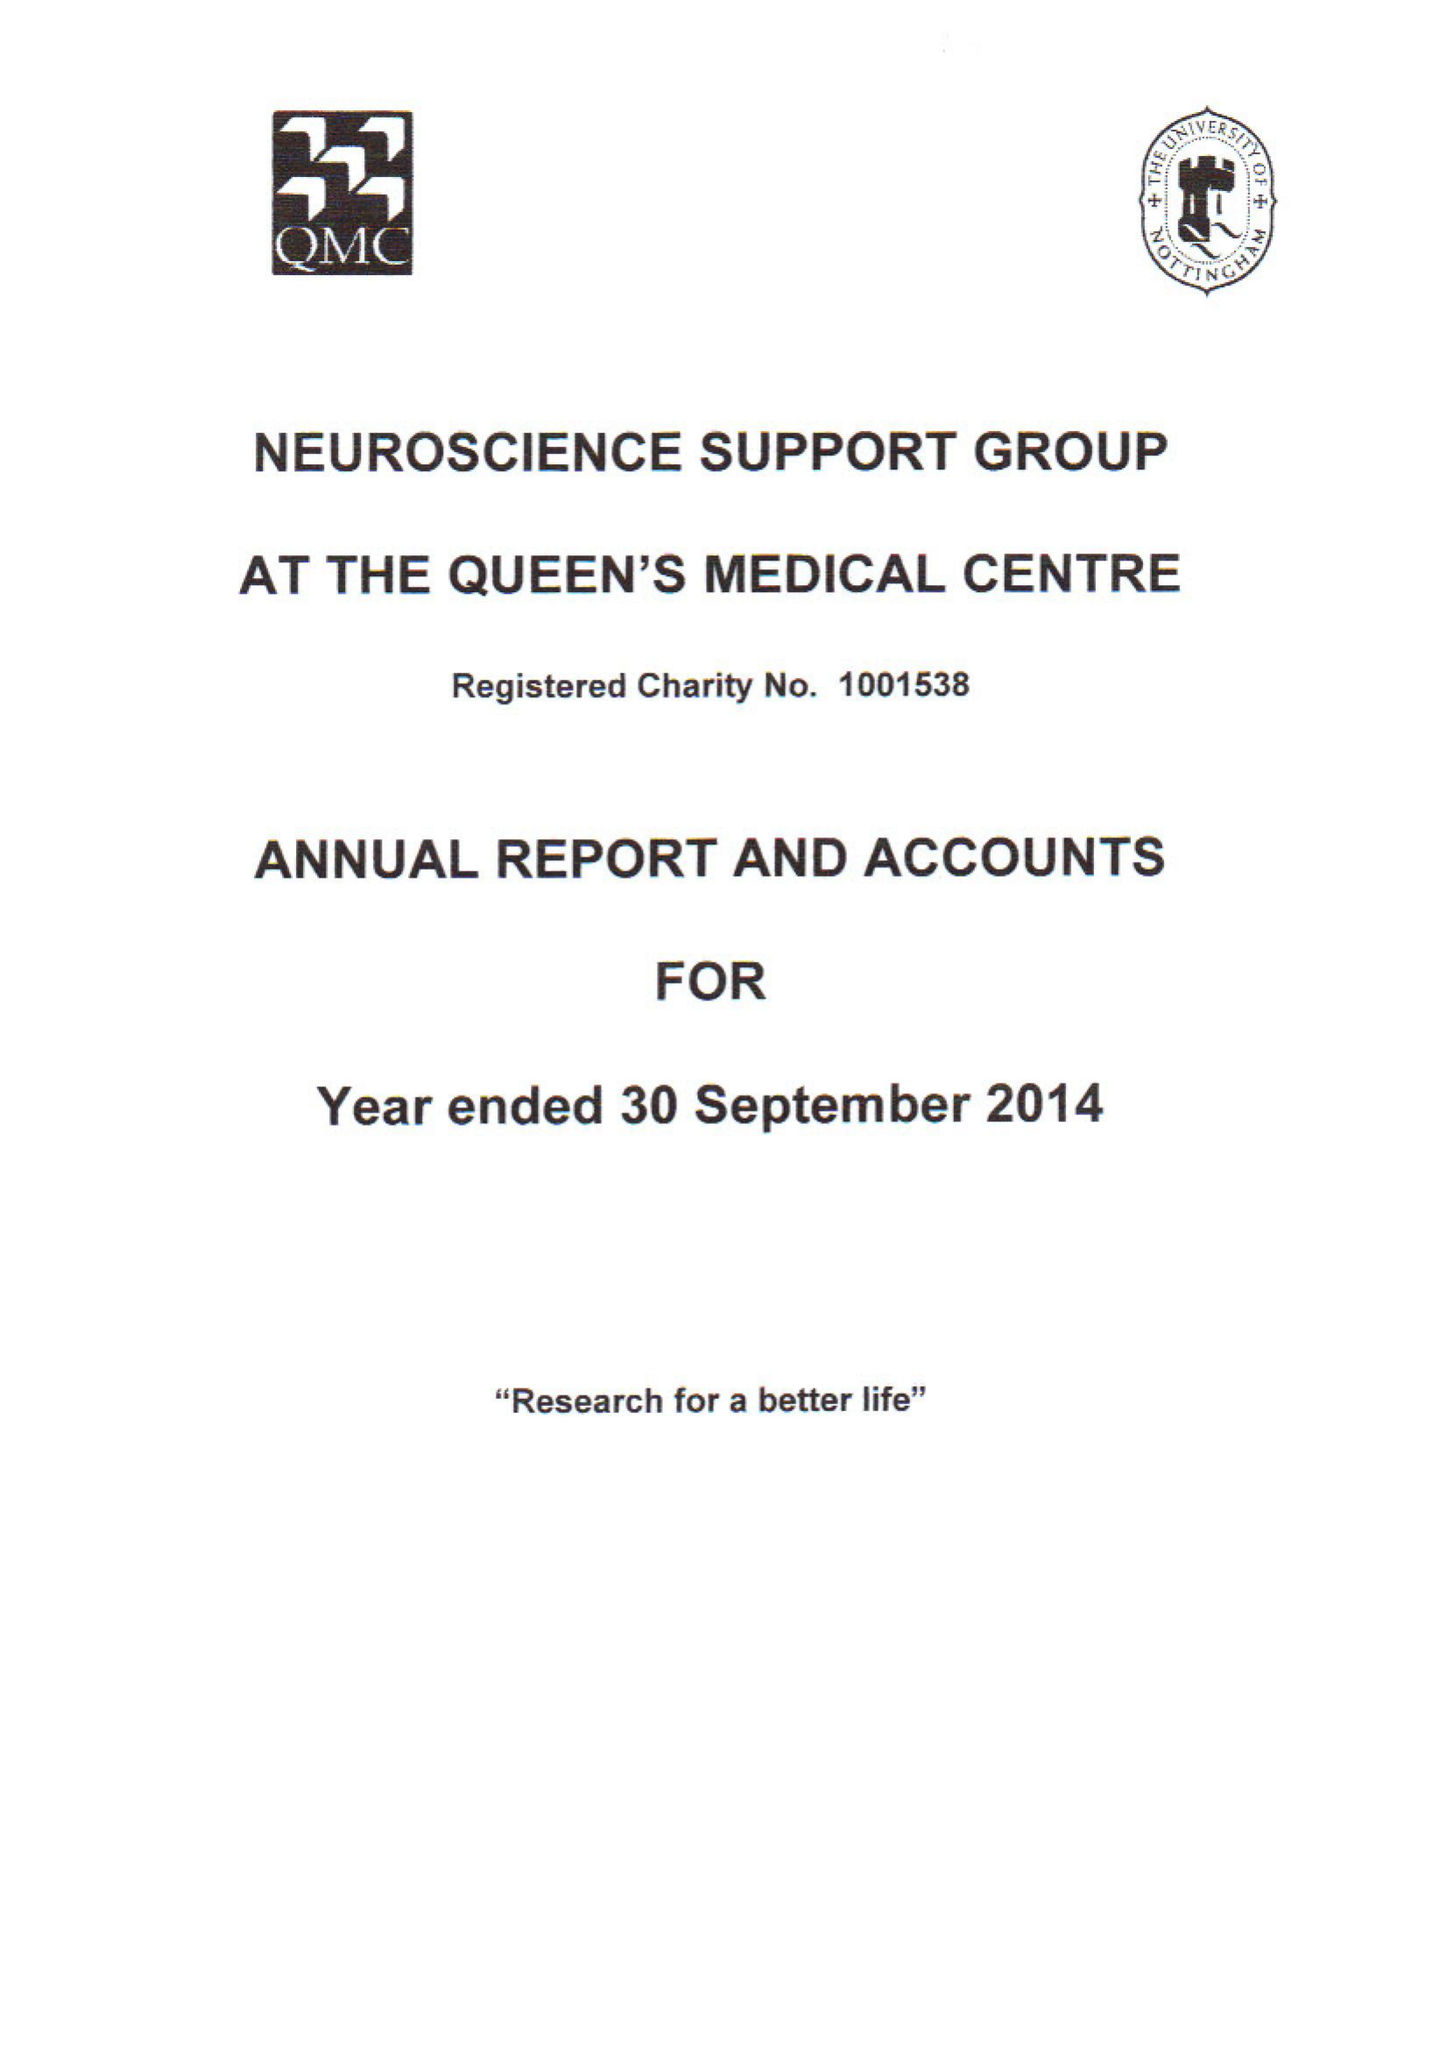What is the value for the address__street_line?
Answer the question using a single word or phrase. 33 GOODWOOD ROAD 